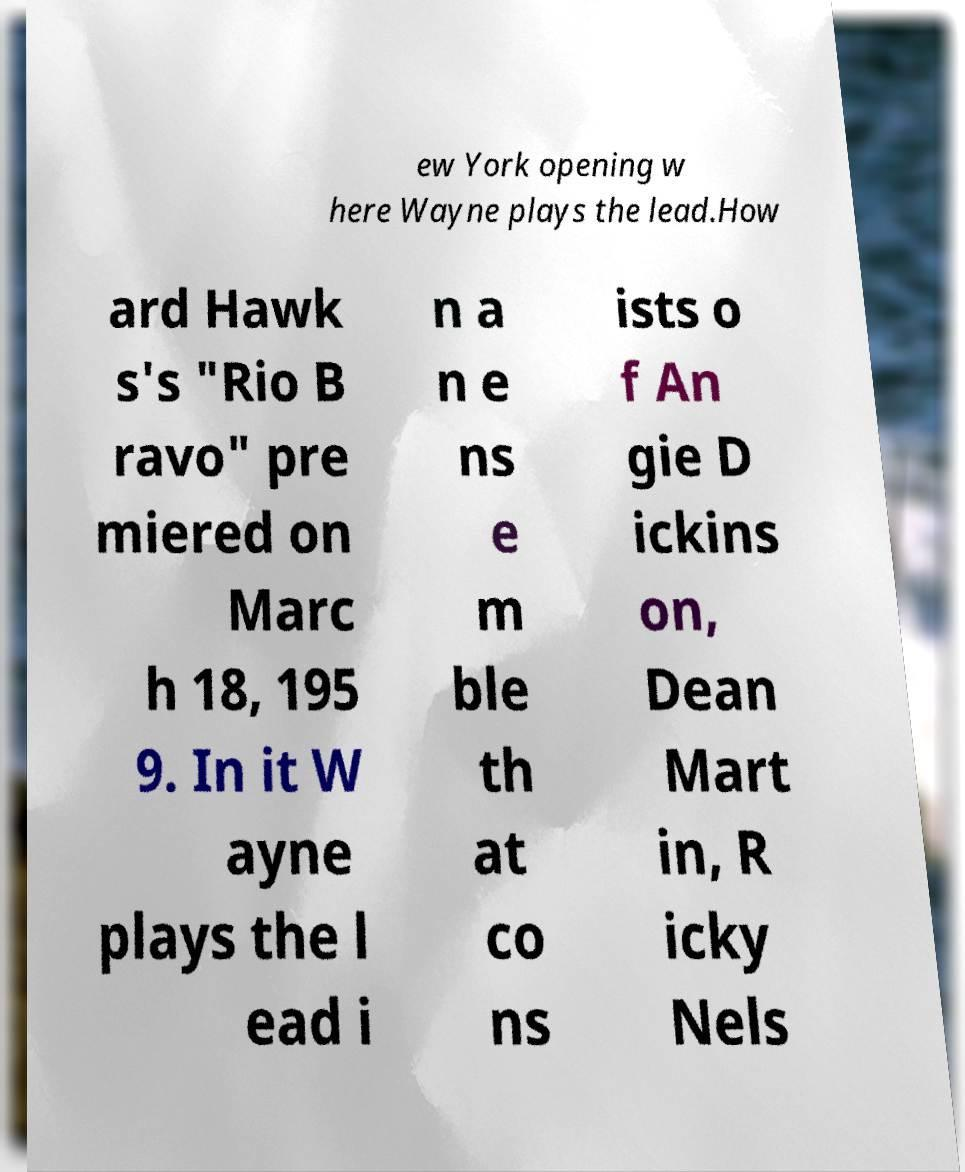Please identify and transcribe the text found in this image. ew York opening w here Wayne plays the lead.How ard Hawk s's "Rio B ravo" pre miered on Marc h 18, 195 9. In it W ayne plays the l ead i n a n e ns e m ble th at co ns ists o f An gie D ickins on, Dean Mart in, R icky Nels 